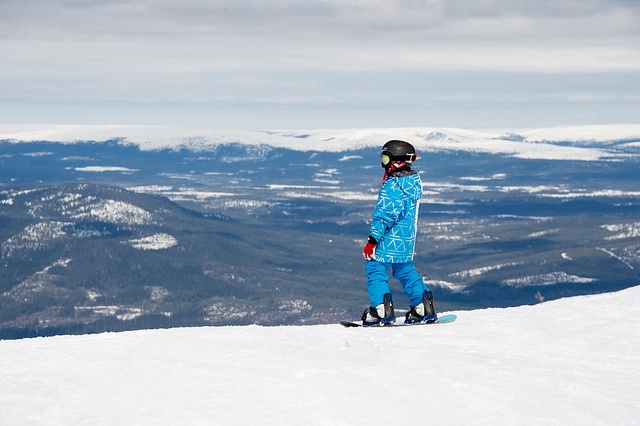Describe the objects in this image and their specific colors. I can see people in darkgray, lightblue, black, blue, and lightgray tones and snowboard in darkgray, gray, lightgray, black, and lightblue tones in this image. 